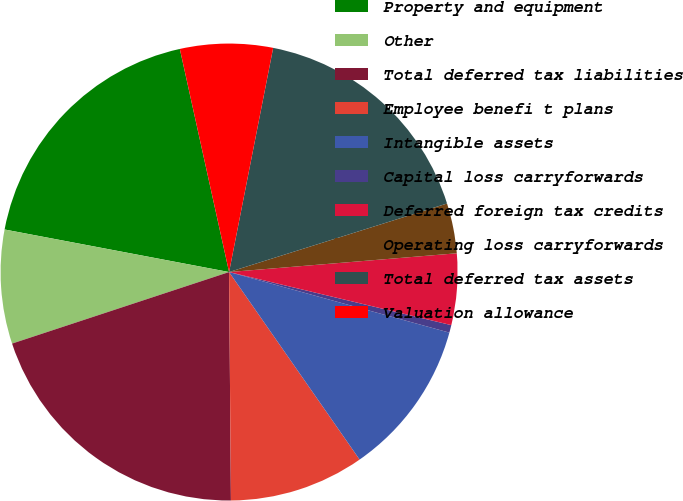Convert chart to OTSL. <chart><loc_0><loc_0><loc_500><loc_500><pie_chart><fcel>Property and equipment<fcel>Other<fcel>Total deferred tax liabilities<fcel>Employee benefi t plans<fcel>Intangible assets<fcel>Capital loss carryforwards<fcel>Deferred foreign tax credits<fcel>Operating loss carryforwards<fcel>Total deferred tax assets<fcel>Valuation allowance<nl><fcel>18.56%<fcel>8.05%<fcel>20.06%<fcel>9.55%<fcel>11.05%<fcel>0.54%<fcel>5.04%<fcel>3.54%<fcel>17.06%<fcel>6.55%<nl></chart> 